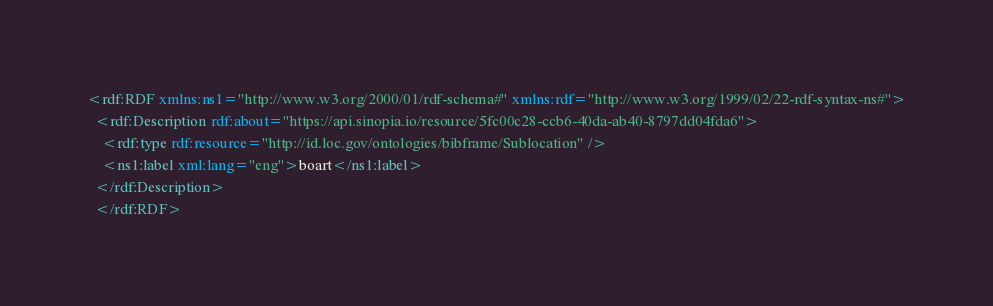Convert code to text. <code><loc_0><loc_0><loc_500><loc_500><_XML_><rdf:RDF xmlns:ns1="http://www.w3.org/2000/01/rdf-schema#" xmlns:rdf="http://www.w3.org/1999/02/22-rdf-syntax-ns#">
  <rdf:Description rdf:about="https://api.sinopia.io/resource/5fc00c28-ccb6-40da-ab40-8797dd04fda6">
    <rdf:type rdf:resource="http://id.loc.gov/ontologies/bibframe/Sublocation" />
    <ns1:label xml:lang="eng">boart</ns1:label>
  </rdf:Description>
  </rdf:RDF></code> 